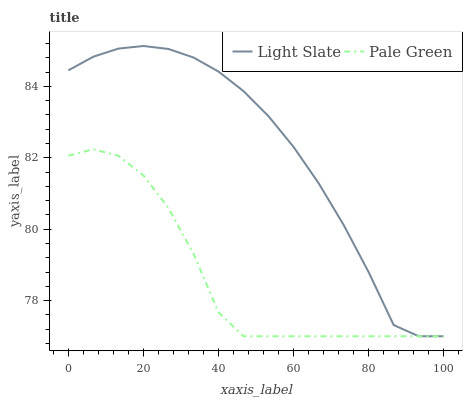Does Pale Green have the minimum area under the curve?
Answer yes or no. Yes. Does Light Slate have the maximum area under the curve?
Answer yes or no. Yes. Does Pale Green have the maximum area under the curve?
Answer yes or no. No. Is Light Slate the smoothest?
Answer yes or no. Yes. Is Pale Green the roughest?
Answer yes or no. Yes. Is Pale Green the smoothest?
Answer yes or no. No. Does Light Slate have the lowest value?
Answer yes or no. Yes. Does Light Slate have the highest value?
Answer yes or no. Yes. Does Pale Green have the highest value?
Answer yes or no. No. Does Pale Green intersect Light Slate?
Answer yes or no. Yes. Is Pale Green less than Light Slate?
Answer yes or no. No. Is Pale Green greater than Light Slate?
Answer yes or no. No. 